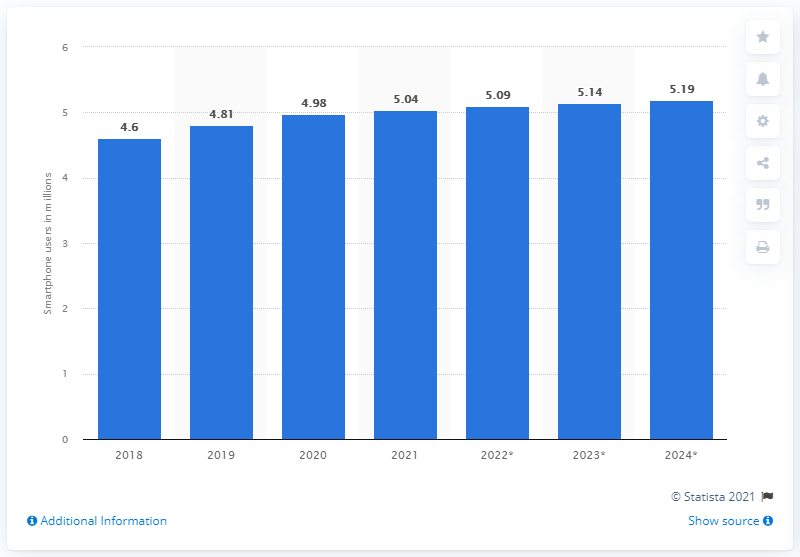Specify some key components in this picture. By the year 2025, it is estimated that there will be approximately 5.19 million smartphone users in Norway. 